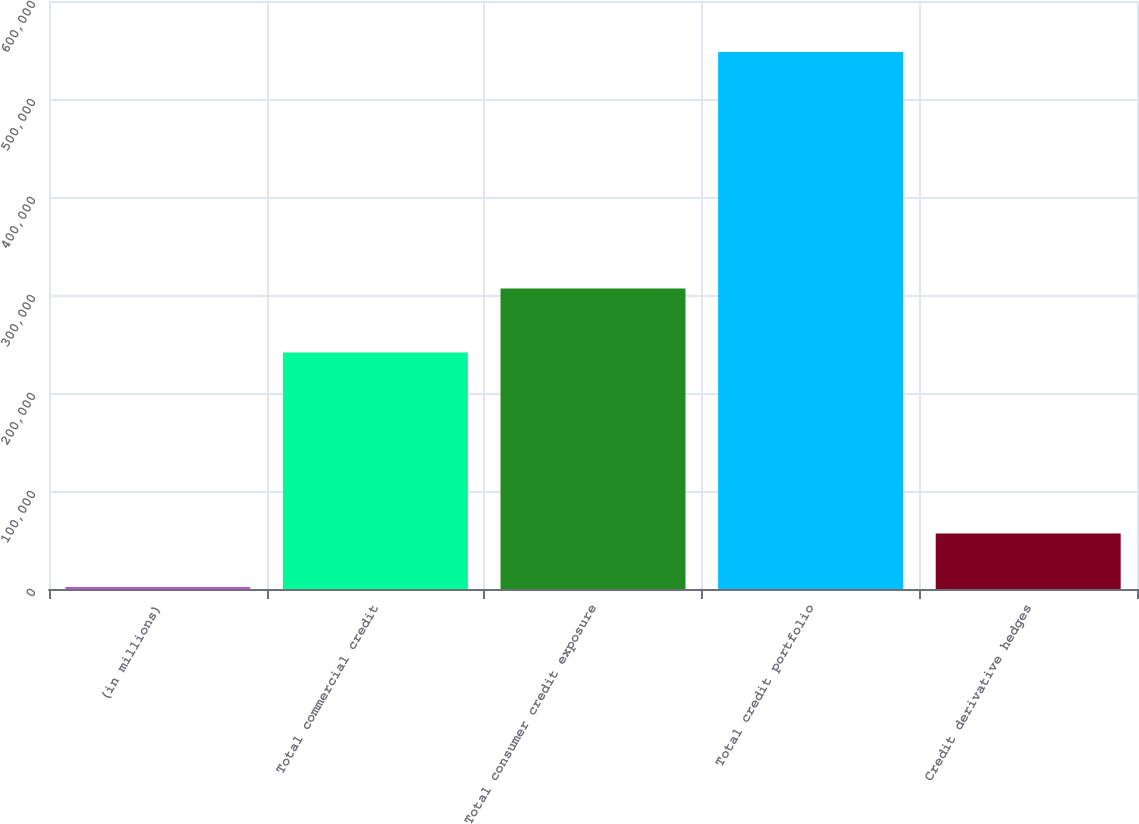Convert chart. <chart><loc_0><loc_0><loc_500><loc_500><bar_chart><fcel>(in millions)<fcel>Total commercial credit<fcel>Total consumer credit exposure<fcel>Total credit portfolio<fcel>Credit derivative hedges<nl><fcel>2002<fcel>241340<fcel>306676<fcel>548016<fcel>56603.4<nl></chart> 